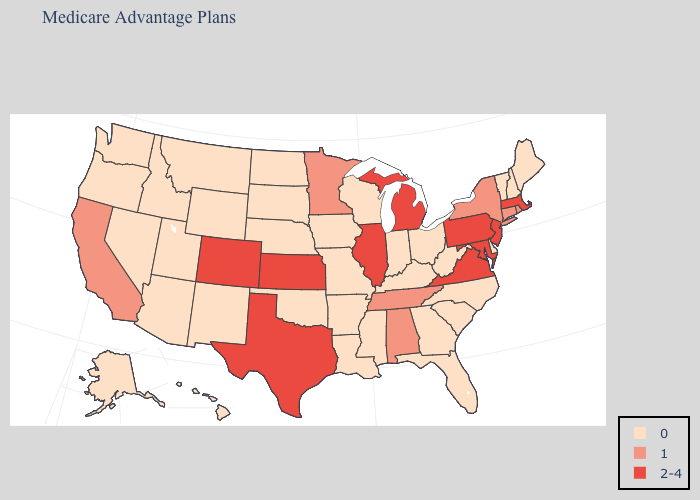Name the states that have a value in the range 2-4?
Give a very brief answer. Colorado, Illinois, Kansas, Massachusetts, Maryland, Michigan, New Jersey, Pennsylvania, Texas, Virginia. Name the states that have a value in the range 0?
Concise answer only. Alaska, Arkansas, Arizona, Delaware, Florida, Georgia, Hawaii, Iowa, Idaho, Indiana, Kentucky, Louisiana, Maine, Missouri, Mississippi, Montana, North Carolina, North Dakota, Nebraska, New Hampshire, New Mexico, Nevada, Ohio, Oklahoma, Oregon, South Carolina, South Dakota, Utah, Vermont, Washington, Wisconsin, West Virginia, Wyoming. Name the states that have a value in the range 1?
Be succinct. Alabama, California, Connecticut, Minnesota, New York, Rhode Island, Tennessee. Name the states that have a value in the range 0?
Quick response, please. Alaska, Arkansas, Arizona, Delaware, Florida, Georgia, Hawaii, Iowa, Idaho, Indiana, Kentucky, Louisiana, Maine, Missouri, Mississippi, Montana, North Carolina, North Dakota, Nebraska, New Hampshire, New Mexico, Nevada, Ohio, Oklahoma, Oregon, South Carolina, South Dakota, Utah, Vermont, Washington, Wisconsin, West Virginia, Wyoming. Does Georgia have a lower value than Florida?
Answer briefly. No. Which states have the highest value in the USA?
Keep it brief. Colorado, Illinois, Kansas, Massachusetts, Maryland, Michigan, New Jersey, Pennsylvania, Texas, Virginia. What is the value of Maine?
Give a very brief answer. 0. Does Montana have the highest value in the USA?
Quick response, please. No. Name the states that have a value in the range 2-4?
Keep it brief. Colorado, Illinois, Kansas, Massachusetts, Maryland, Michigan, New Jersey, Pennsylvania, Texas, Virginia. What is the value of South Dakota?
Write a very short answer. 0. What is the lowest value in states that border Kansas?
Quick response, please. 0. Which states hav the highest value in the MidWest?
Write a very short answer. Illinois, Kansas, Michigan. Does the map have missing data?
Keep it brief. No. Does Arkansas have the same value as California?
Keep it brief. No. 